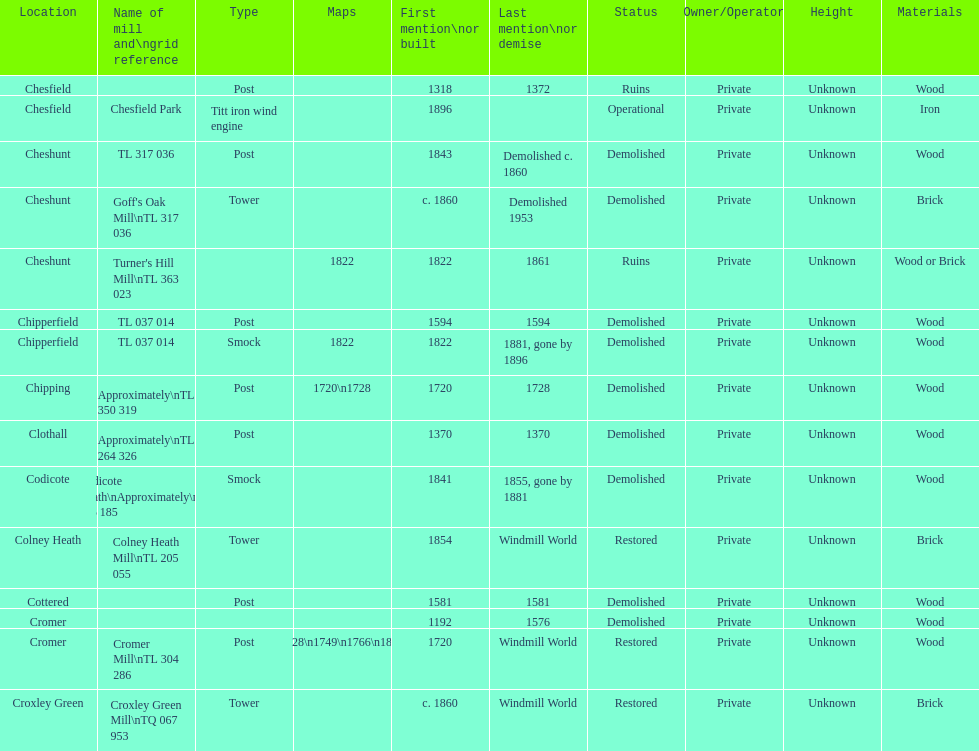What is the number of mills first mentioned or built in the 1800s? 8. 